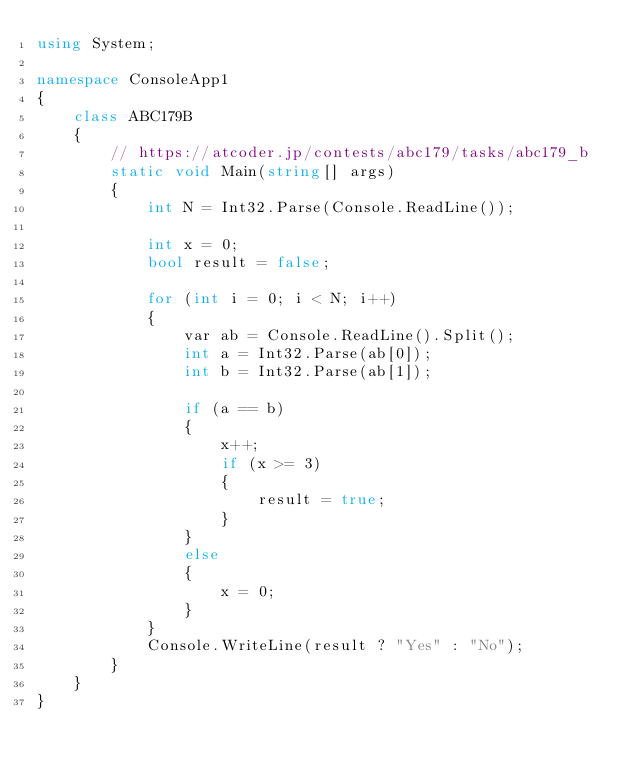<code> <loc_0><loc_0><loc_500><loc_500><_C#_>using System;

namespace ConsoleApp1
{
    class ABC179B
    {
        // https://atcoder.jp/contests/abc179/tasks/abc179_b
        static void Main(string[] args)
        {
            int N = Int32.Parse(Console.ReadLine());

            int x = 0;
            bool result = false;

            for (int i = 0; i < N; i++)
            {
                var ab = Console.ReadLine().Split();
                int a = Int32.Parse(ab[0]);
                int b = Int32.Parse(ab[1]);

                if (a == b)
                {
                    x++;
                    if (x >= 3)
                    {
                        result = true;
                    }
                }
                else
                {
                    x = 0;
                }
            }
            Console.WriteLine(result ? "Yes" : "No");
        }
    }
}
</code> 